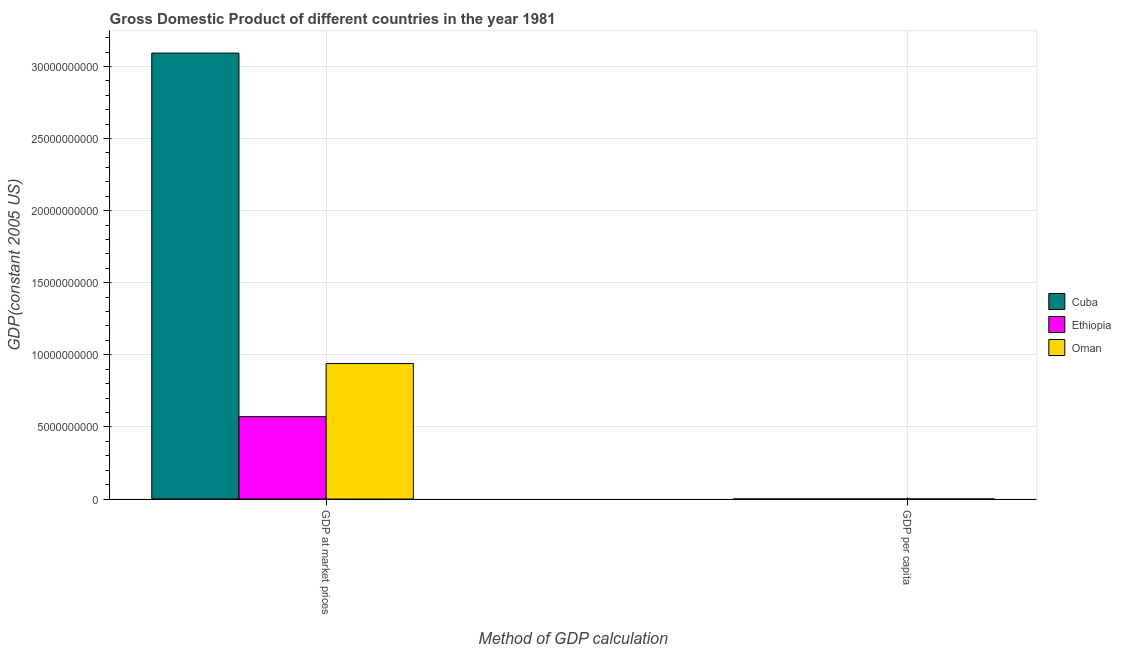How many groups of bars are there?
Ensure brevity in your answer.  2. Are the number of bars per tick equal to the number of legend labels?
Provide a short and direct response. Yes. Are the number of bars on each tick of the X-axis equal?
Offer a very short reply. Yes. How many bars are there on the 2nd tick from the right?
Give a very brief answer. 3. What is the label of the 2nd group of bars from the left?
Your answer should be compact. GDP per capita. What is the gdp at market prices in Ethiopia?
Your answer should be very brief. 5.71e+09. Across all countries, what is the maximum gdp per capita?
Make the answer very short. 7698.85. Across all countries, what is the minimum gdp at market prices?
Your response must be concise. 5.71e+09. In which country was the gdp at market prices maximum?
Provide a succinct answer. Cuba. In which country was the gdp per capita minimum?
Offer a terse response. Ethiopia. What is the total gdp at market prices in the graph?
Provide a succinct answer. 4.60e+1. What is the difference between the gdp at market prices in Cuba and that in Ethiopia?
Make the answer very short. 2.52e+1. What is the difference between the gdp per capita in Oman and the gdp at market prices in Cuba?
Ensure brevity in your answer.  -3.09e+1. What is the average gdp per capita per country?
Your response must be concise. 3661.91. What is the difference between the gdp per capita and gdp at market prices in Oman?
Provide a succinct answer. -9.40e+09. What is the ratio of the gdp at market prices in Ethiopia to that in Cuba?
Give a very brief answer. 0.18. What does the 1st bar from the left in GDP at market prices represents?
Offer a very short reply. Cuba. What does the 1st bar from the right in GDP per capita represents?
Offer a terse response. Oman. How many bars are there?
Provide a short and direct response. 6. What is the difference between two consecutive major ticks on the Y-axis?
Ensure brevity in your answer.  5.00e+09. Are the values on the major ticks of Y-axis written in scientific E-notation?
Ensure brevity in your answer.  No. What is the title of the graph?
Offer a very short reply. Gross Domestic Product of different countries in the year 1981. What is the label or title of the X-axis?
Keep it short and to the point. Method of GDP calculation. What is the label or title of the Y-axis?
Provide a succinct answer. GDP(constant 2005 US). What is the GDP(constant 2005 US) in Cuba in GDP at market prices?
Make the answer very short. 3.09e+1. What is the GDP(constant 2005 US) of Ethiopia in GDP at market prices?
Offer a very short reply. 5.71e+09. What is the GDP(constant 2005 US) of Oman in GDP at market prices?
Give a very brief answer. 9.40e+09. What is the GDP(constant 2005 US) of Cuba in GDP per capita?
Ensure brevity in your answer.  3128.62. What is the GDP(constant 2005 US) in Ethiopia in GDP per capita?
Offer a terse response. 158.27. What is the GDP(constant 2005 US) in Oman in GDP per capita?
Your answer should be very brief. 7698.85. Across all Method of GDP calculation, what is the maximum GDP(constant 2005 US) of Cuba?
Provide a succinct answer. 3.09e+1. Across all Method of GDP calculation, what is the maximum GDP(constant 2005 US) in Ethiopia?
Offer a terse response. 5.71e+09. Across all Method of GDP calculation, what is the maximum GDP(constant 2005 US) in Oman?
Provide a short and direct response. 9.40e+09. Across all Method of GDP calculation, what is the minimum GDP(constant 2005 US) of Cuba?
Offer a very short reply. 3128.62. Across all Method of GDP calculation, what is the minimum GDP(constant 2005 US) of Ethiopia?
Ensure brevity in your answer.  158.27. Across all Method of GDP calculation, what is the minimum GDP(constant 2005 US) in Oman?
Your answer should be compact. 7698.85. What is the total GDP(constant 2005 US) of Cuba in the graph?
Make the answer very short. 3.09e+1. What is the total GDP(constant 2005 US) in Ethiopia in the graph?
Provide a short and direct response. 5.71e+09. What is the total GDP(constant 2005 US) in Oman in the graph?
Keep it short and to the point. 9.40e+09. What is the difference between the GDP(constant 2005 US) in Cuba in GDP at market prices and that in GDP per capita?
Provide a succinct answer. 3.09e+1. What is the difference between the GDP(constant 2005 US) of Ethiopia in GDP at market prices and that in GDP per capita?
Give a very brief answer. 5.71e+09. What is the difference between the GDP(constant 2005 US) in Oman in GDP at market prices and that in GDP per capita?
Provide a short and direct response. 9.40e+09. What is the difference between the GDP(constant 2005 US) of Cuba in GDP at market prices and the GDP(constant 2005 US) of Ethiopia in GDP per capita?
Ensure brevity in your answer.  3.09e+1. What is the difference between the GDP(constant 2005 US) in Cuba in GDP at market prices and the GDP(constant 2005 US) in Oman in GDP per capita?
Make the answer very short. 3.09e+1. What is the difference between the GDP(constant 2005 US) in Ethiopia in GDP at market prices and the GDP(constant 2005 US) in Oman in GDP per capita?
Your response must be concise. 5.71e+09. What is the average GDP(constant 2005 US) of Cuba per Method of GDP calculation?
Provide a succinct answer. 1.55e+1. What is the average GDP(constant 2005 US) of Ethiopia per Method of GDP calculation?
Offer a very short reply. 2.86e+09. What is the average GDP(constant 2005 US) in Oman per Method of GDP calculation?
Give a very brief answer. 4.70e+09. What is the difference between the GDP(constant 2005 US) in Cuba and GDP(constant 2005 US) in Ethiopia in GDP at market prices?
Your response must be concise. 2.52e+1. What is the difference between the GDP(constant 2005 US) in Cuba and GDP(constant 2005 US) in Oman in GDP at market prices?
Offer a very short reply. 2.15e+1. What is the difference between the GDP(constant 2005 US) in Ethiopia and GDP(constant 2005 US) in Oman in GDP at market prices?
Give a very brief answer. -3.68e+09. What is the difference between the GDP(constant 2005 US) in Cuba and GDP(constant 2005 US) in Ethiopia in GDP per capita?
Your answer should be compact. 2970.35. What is the difference between the GDP(constant 2005 US) of Cuba and GDP(constant 2005 US) of Oman in GDP per capita?
Make the answer very short. -4570.23. What is the difference between the GDP(constant 2005 US) of Ethiopia and GDP(constant 2005 US) of Oman in GDP per capita?
Ensure brevity in your answer.  -7540.57. What is the ratio of the GDP(constant 2005 US) of Cuba in GDP at market prices to that in GDP per capita?
Give a very brief answer. 9.88e+06. What is the ratio of the GDP(constant 2005 US) of Ethiopia in GDP at market prices to that in GDP per capita?
Ensure brevity in your answer.  3.61e+07. What is the ratio of the GDP(constant 2005 US) of Oman in GDP at market prices to that in GDP per capita?
Ensure brevity in your answer.  1.22e+06. What is the difference between the highest and the second highest GDP(constant 2005 US) in Cuba?
Offer a terse response. 3.09e+1. What is the difference between the highest and the second highest GDP(constant 2005 US) in Ethiopia?
Your answer should be very brief. 5.71e+09. What is the difference between the highest and the second highest GDP(constant 2005 US) of Oman?
Ensure brevity in your answer.  9.40e+09. What is the difference between the highest and the lowest GDP(constant 2005 US) in Cuba?
Keep it short and to the point. 3.09e+1. What is the difference between the highest and the lowest GDP(constant 2005 US) in Ethiopia?
Provide a succinct answer. 5.71e+09. What is the difference between the highest and the lowest GDP(constant 2005 US) of Oman?
Provide a succinct answer. 9.40e+09. 